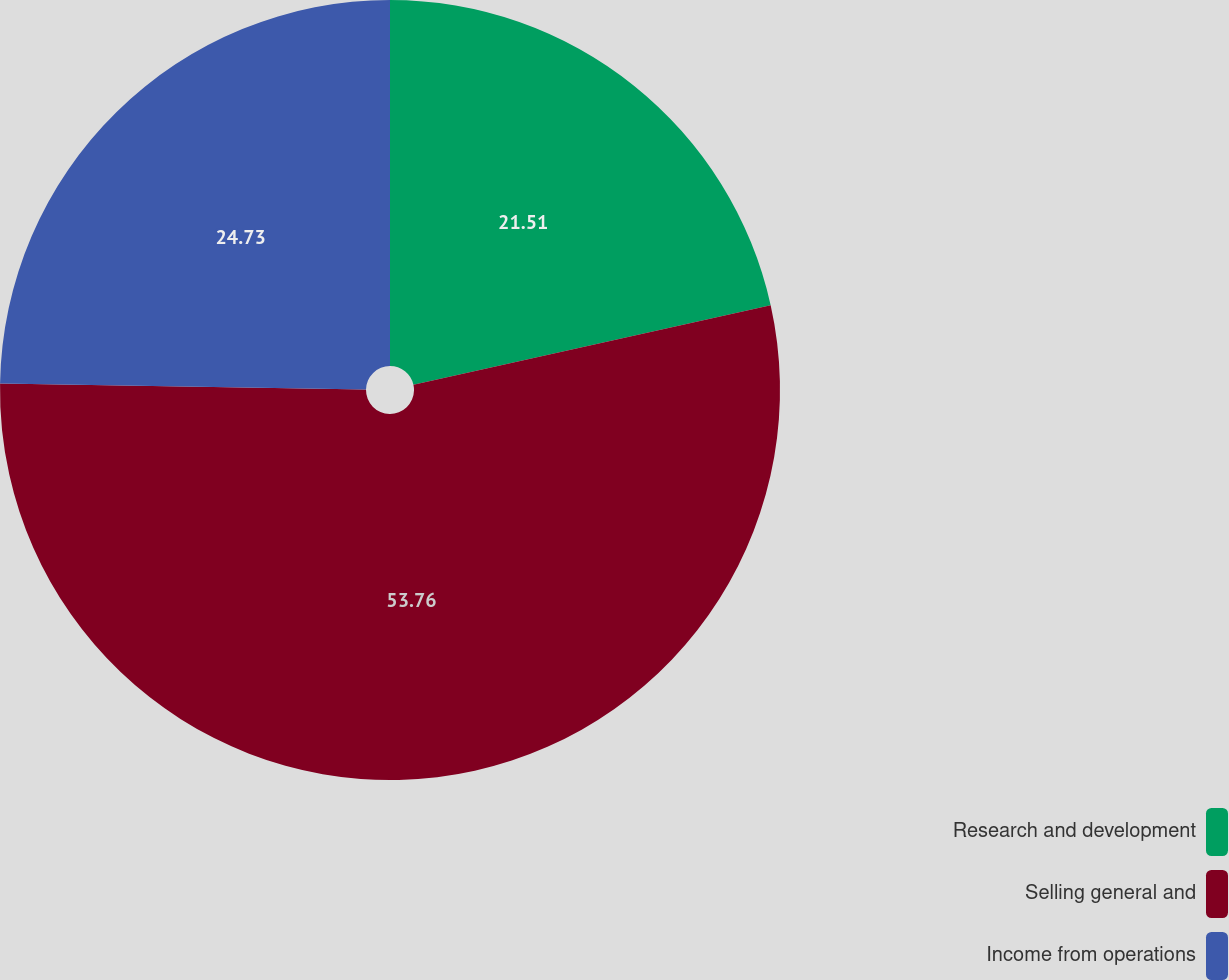Convert chart to OTSL. <chart><loc_0><loc_0><loc_500><loc_500><pie_chart><fcel>Research and development<fcel>Selling general and<fcel>Income from operations<nl><fcel>21.51%<fcel>53.76%<fcel>24.73%<nl></chart> 